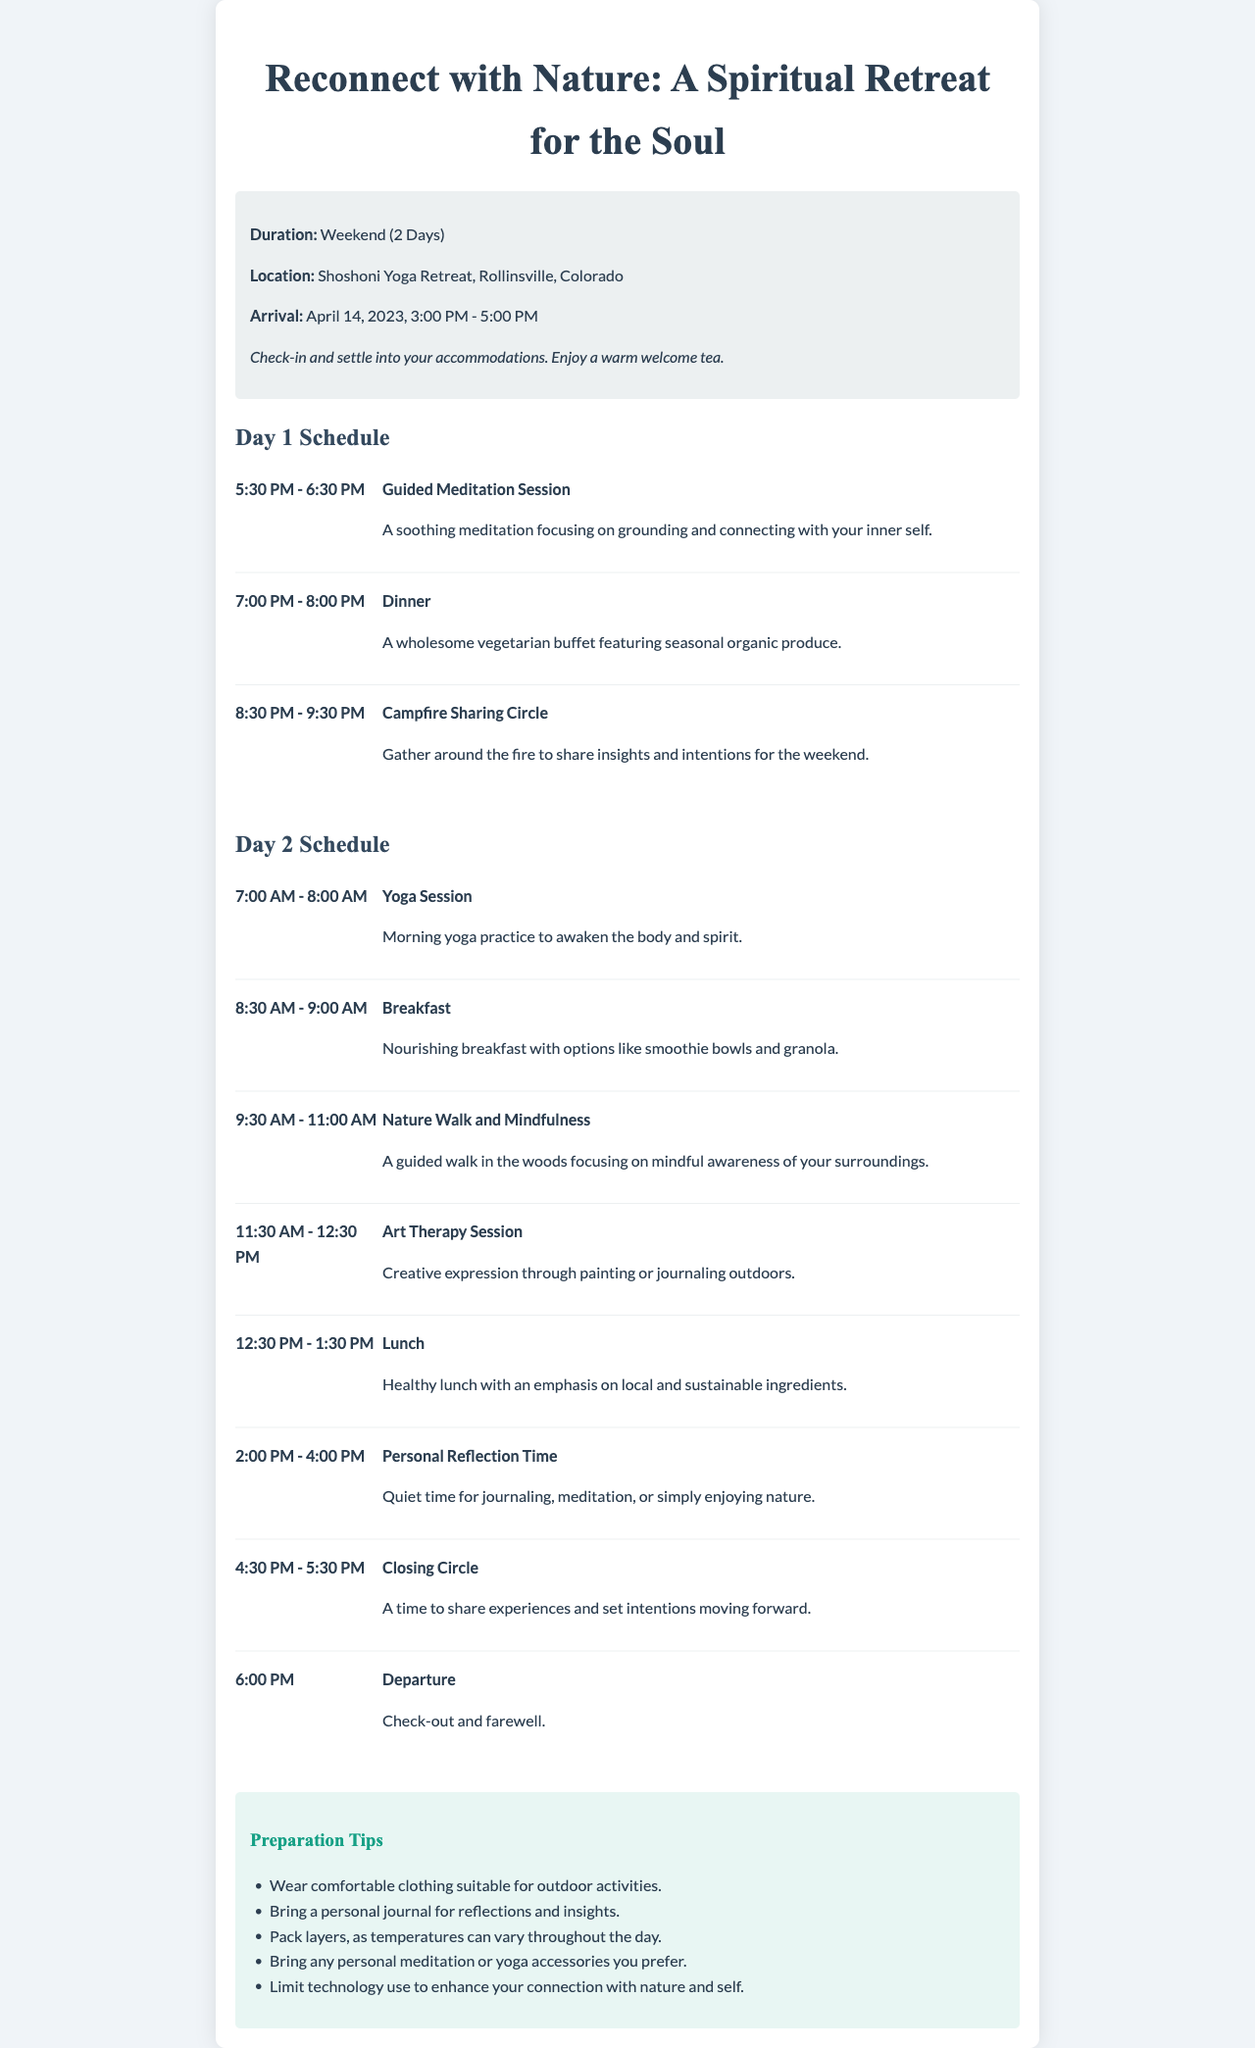What is the duration of the retreat? The duration of the retreat is mentioned in the document as "Weekend (2 Days)."
Answer: Weekend (2 Days) Where is the retreat located? The location is specified in the document as "Shoshoni Yoga Retreat, Rollinsville, Colorado."
Answer: Shoshoni Yoga Retreat, Rollinsville, Colorado What time does the check-in start? The check-in time is noted in the document as "3:00 PM."
Answer: 3:00 PM How many guided meditation sessions are scheduled? The document lists one guided meditation session on Day 1.
Answer: 1 What is the focus of the Nature Walk and Mindfulness activity? The theme of this activity is highlighted in the document as "mindful awareness of your surroundings."
Answer: mindful awareness of your surroundings What should participants wear for the retreat? The document advises wearing "comfortable clothing suitable for outdoor activities."
Answer: comfortable clothing suitable for outdoor activities What kind of breakfast is offered on Day 2? The breakfast type is described in the document as "Nourishing breakfast with options like smoothie bowls and granola."
Answer: Nourishing breakfast with options like smoothie bowls and granola What activity concludes the retreat? The final activity is a "Closing Circle" described before departure.
Answer: Closing Circle 